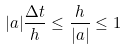Convert formula to latex. <formula><loc_0><loc_0><loc_500><loc_500>| a | \frac { \Delta t } { h } \leq \frac { h } { | a | } \leq 1</formula> 